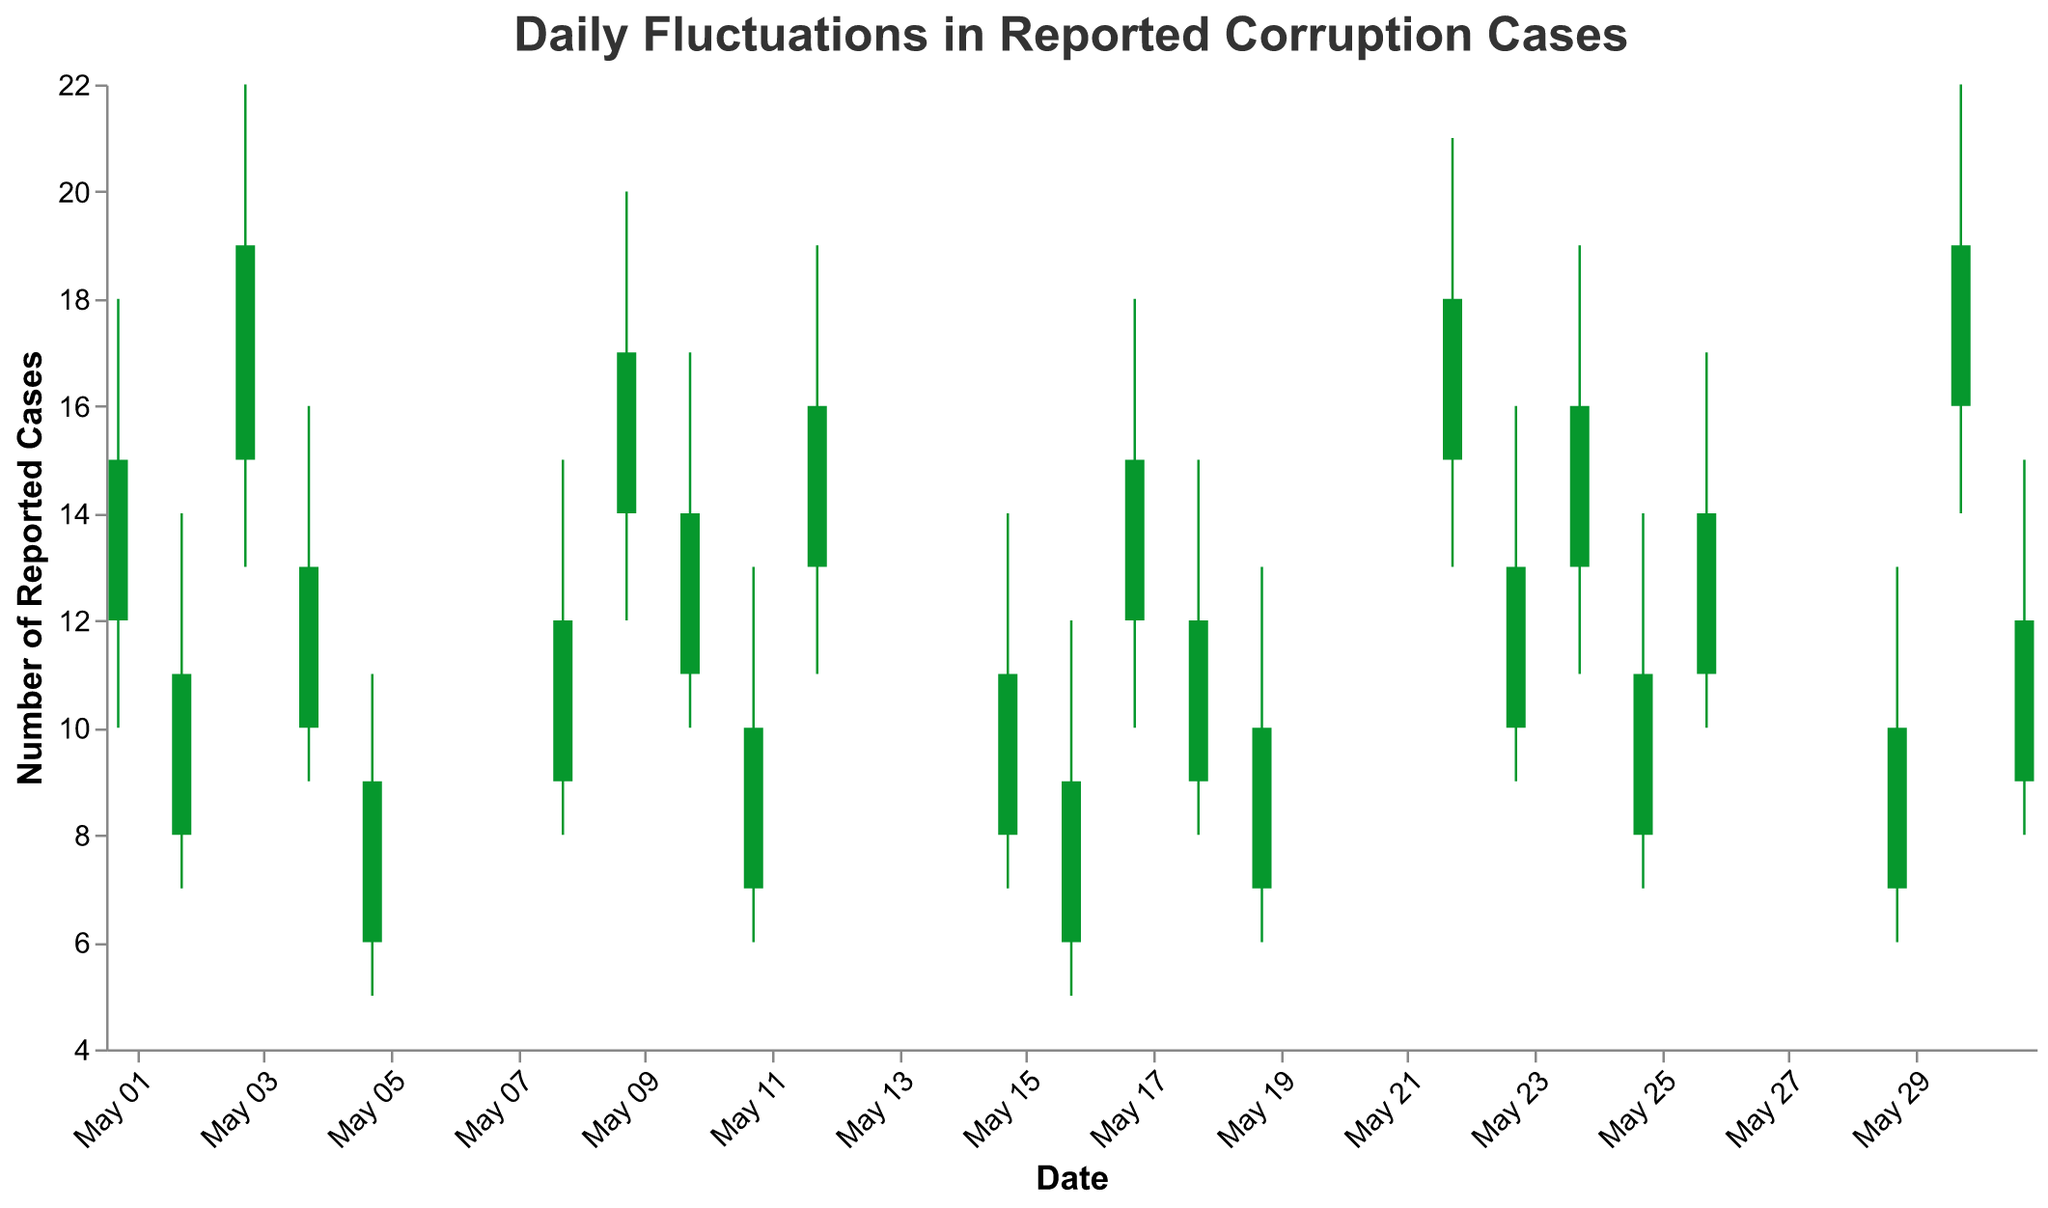What is the title of the chart? The title of the chart is displayed at the top in larger font size and reads "Daily Fluctuations in Reported Corruption Cases".
Answer: Daily Fluctuations in Reported Corruption Cases What are the date ranges covered by the chart? The x-axis represents the dates, which range from May 1, 2023, to May 31, 2023. The specific dates can be inferred from the data listed.
Answer: May 1, 2023, to May 31, 2023 Which department had the highest number of reported corruption cases on May 3, 2023? On May 3, 2023, the "High" value would indicate the highest number of reported cases for the Ministry of Education. This value is 22.
Answer: Ministry of Education On which date did the Ministry of Justice report the highest number of corruption cases? By looking at the "High" values for the Ministry of Justice on May 9, 2023 (20 cases) and May 30, 2023 (22 cases), we see that May 30, 2023, had the highest value.
Answer: May 30, 2023 How many times did the Ministry of Finance report cases within a single month? The Ministry of Finance reported cases on May 1, 2023, and May 22, 2023, so it reported cases twice in the given month.
Answer: 2 times Compare the fluctuations in reported cases between the Ministry of Health on May 2 and May 23, 2023. On May 2, the Ministry of Health's fluctuation (High-Low) is 7 (14-7), and on May 23, it is also 7 (16-9). The fluctuations are equal.
Answer: Equal Which department had the lowest "Low" value throughout the month of May 2023? The lowest "Low" value is 5, and this occurred for the Ministry of Defense on May 5, 2023, and the Ministry of Culture on May 16, 2023.
Answer: Ministry of Defense, Ministry of Culture What is the average of the "Close" values for the Ministry of Agriculture across all reported days? For the Ministry of Agriculture on May 8, the "Close" value is 12, and on May 29, it is 10. The average is (12 + 10) / 2 = 11.
Answer: 11 Identify the department with the highest fluctuation (High-Low) reported in May 2023. Comparing the High and Low values for all days, the Ministry of Education on May 3, 2023, had the largest fluctuation with a difference of 9 (22-13).
Answer: Ministry of Education How do visual cues indicate whether the number of reported cases increased or decreased from Open to Close? The color of the bars indicates whether reported cases increased (green) or decreased (red) from Open to Close values.
Answer: Color of bars 